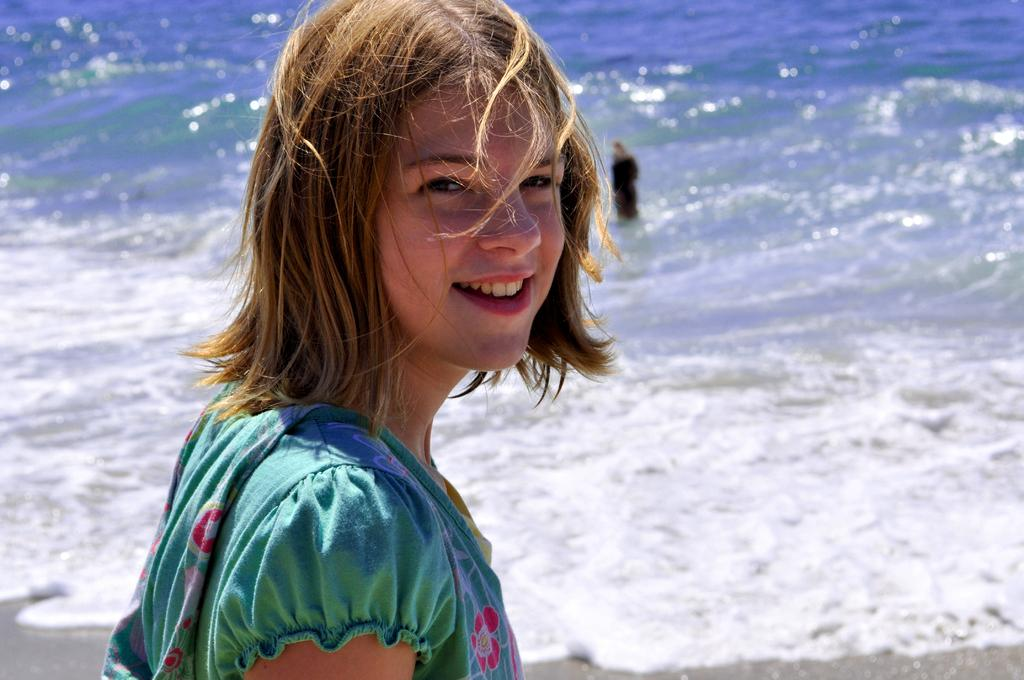Who is present in the image? There is a woman in the image. What is the woman doing in the image? The woman is smiling in the image. What is the woman wearing in the image? The woman is wearing a green dress in the image. What can be seen in the background of the image? There is water visible in the image, which appears to be the sea with waves. Can you describe the person in the background of the image? There is a person standing in the water in the background of the image. How many riddles can be solved by the woman in the image? There is no indication in the image that the woman is solving riddles, so it cannot be determined from the picture. 